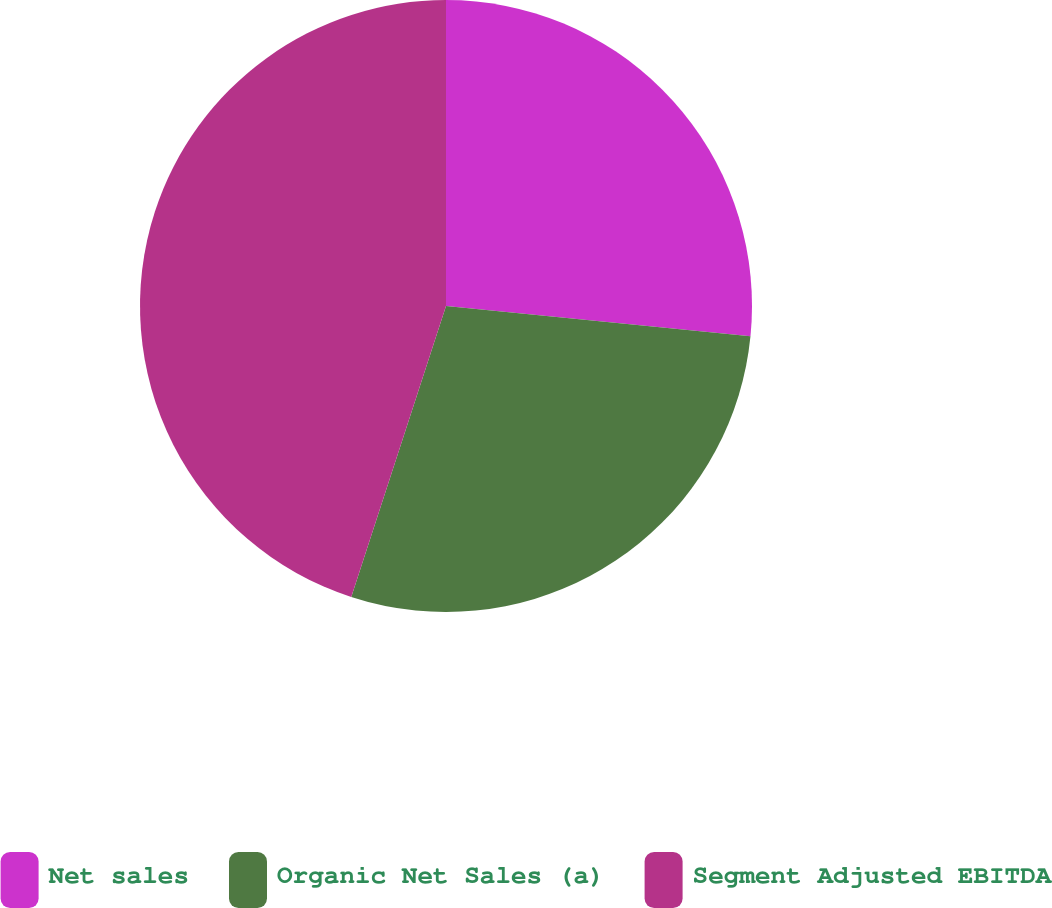Convert chart to OTSL. <chart><loc_0><loc_0><loc_500><loc_500><pie_chart><fcel>Net sales<fcel>Organic Net Sales (a)<fcel>Segment Adjusted EBITDA<nl><fcel>26.58%<fcel>28.43%<fcel>44.99%<nl></chart> 